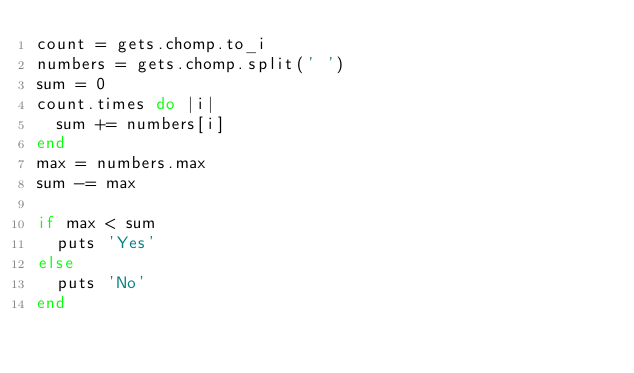Convert code to text. <code><loc_0><loc_0><loc_500><loc_500><_Ruby_>count = gets.chomp.to_i
numbers = gets.chomp.split(' ')
sum = 0
count.times do |i|
  sum += numbers[i]
end 
max = numbers.max
sum -= max 
 
if max < sum
  puts 'Yes'
else
  puts 'No'
end </code> 